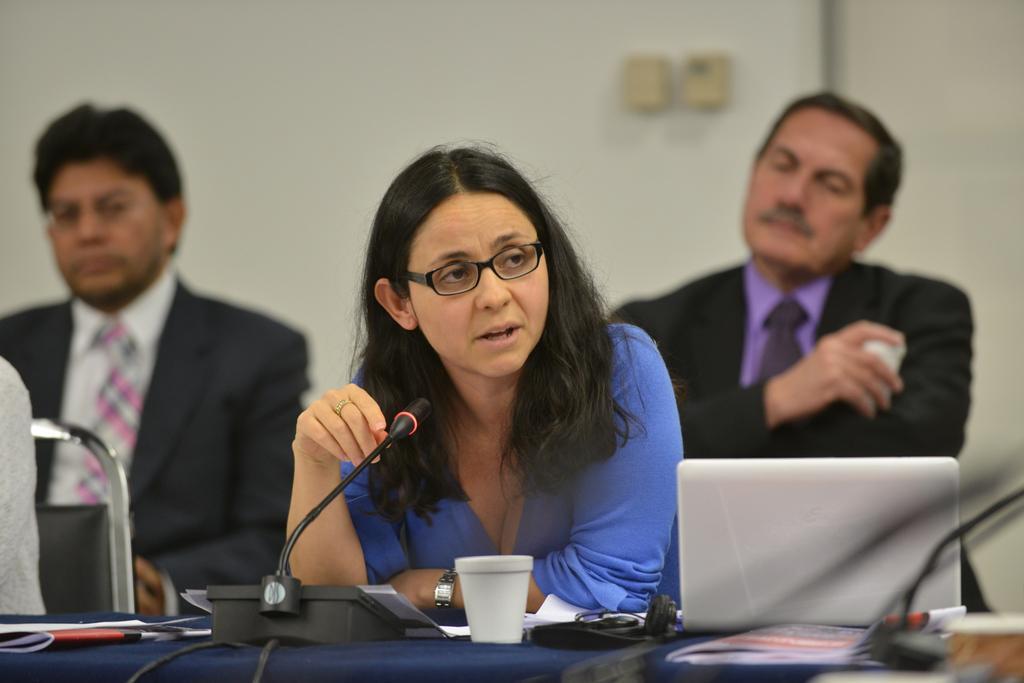Can you describe this image briefly? In this image I can see three persons sitting, in front the person is wearing blue shirt holding a microphone. I can also see few glasses and laptop on the table, at back I can see a person wearing black blazer, purple shirt. At left I can see the other person wearing black blazer, white shirt, white and pink tie, at back wall is in white color. 